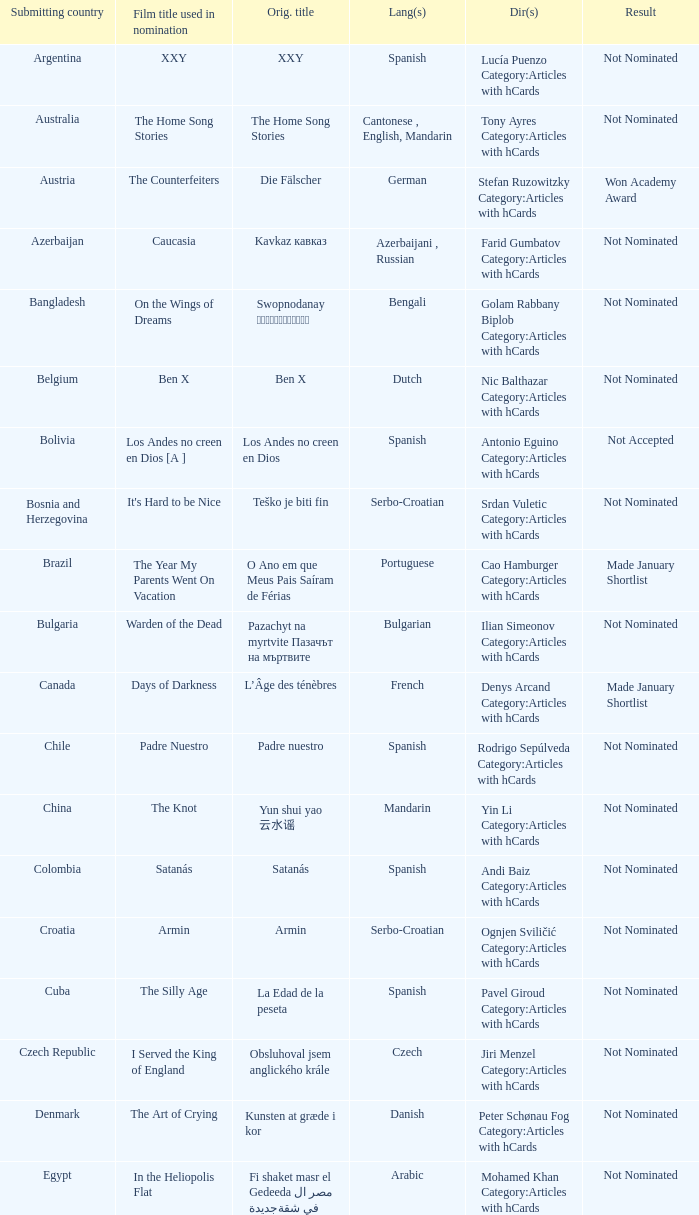What country submitted the movie the orphanage? Spain. 